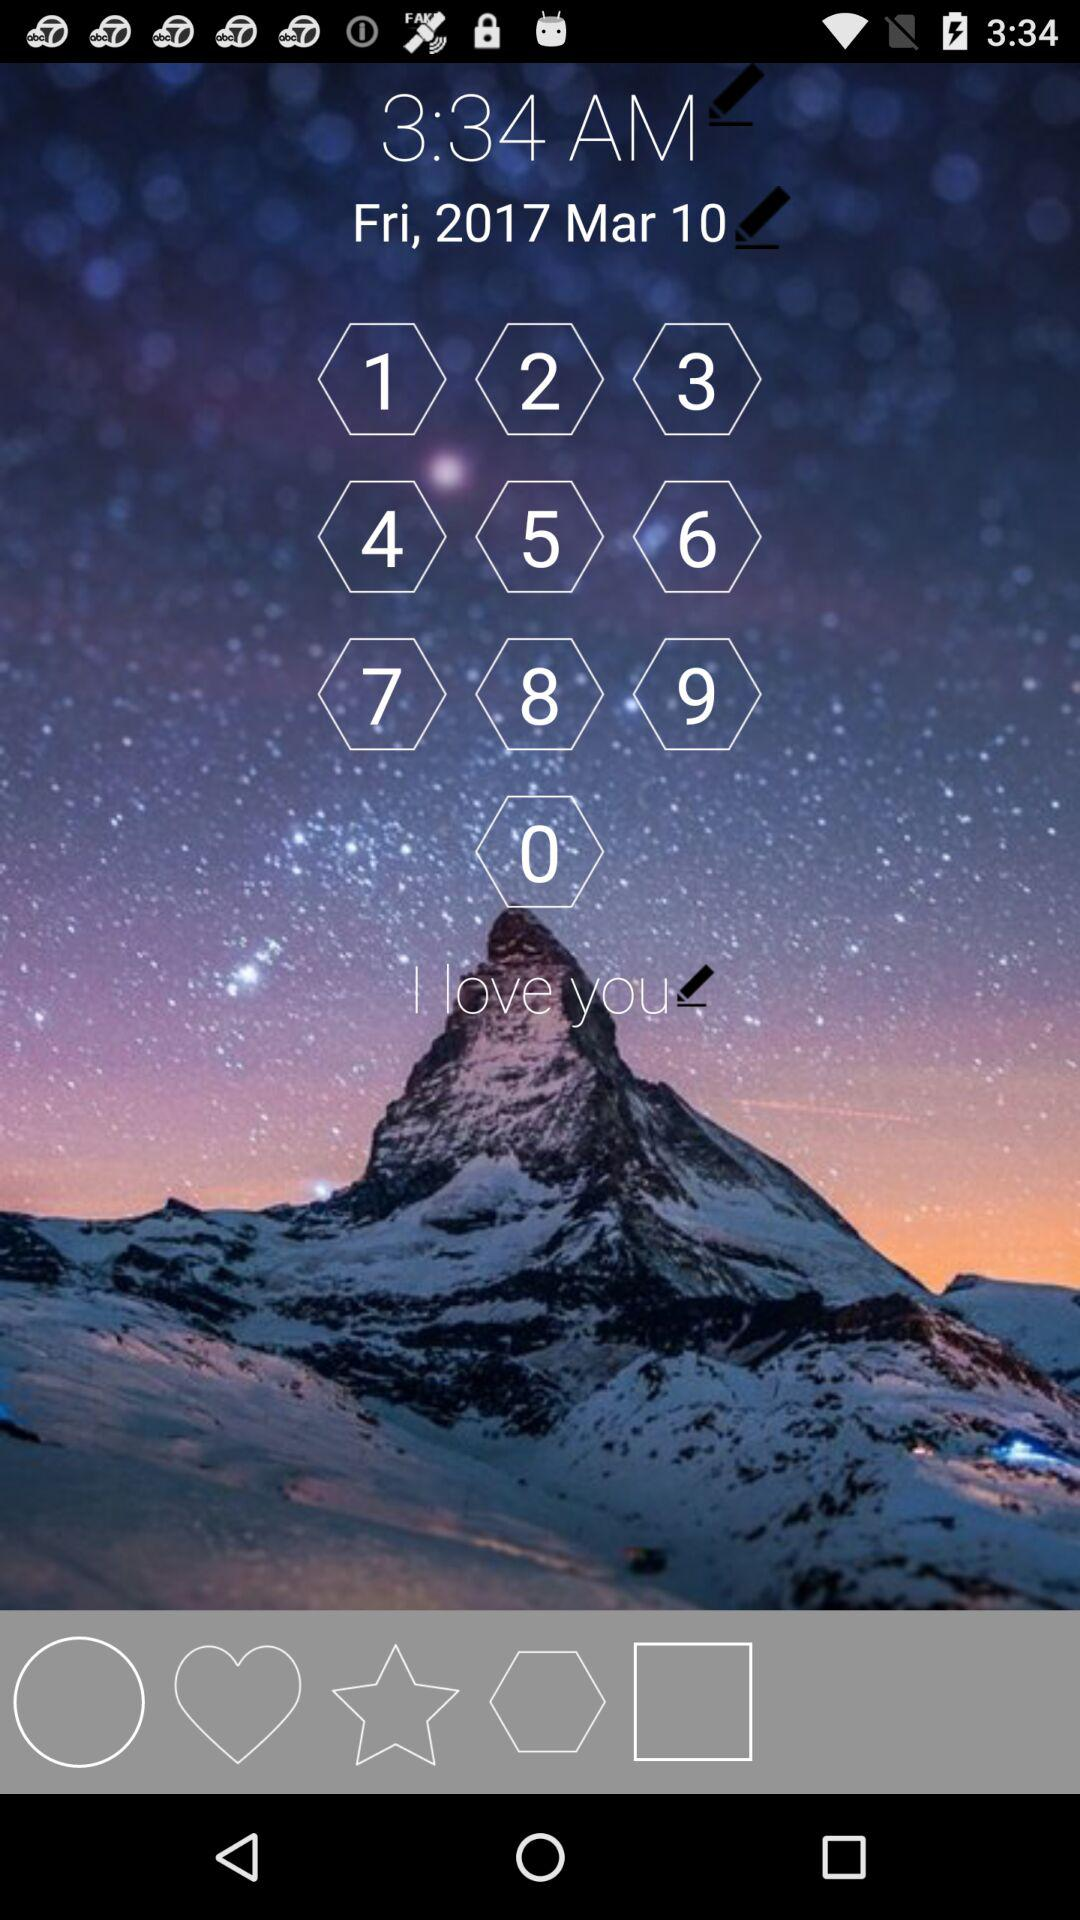What is the date? The date is Friday, March 10, 2017. 